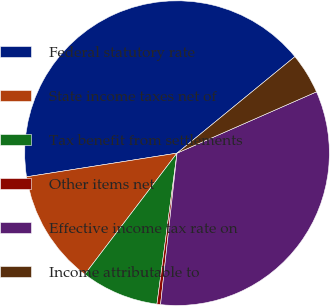<chart> <loc_0><loc_0><loc_500><loc_500><pie_chart><fcel>Federal statutory rate<fcel>State income taxes net of<fcel>Tax benefit from settlements<fcel>Other items net<fcel>Effective income tax rate on<fcel>Income attributable to<nl><fcel>41.57%<fcel>12.16%<fcel>8.25%<fcel>0.38%<fcel>33.32%<fcel>4.33%<nl></chart> 